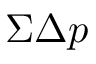Convert formula to latex. <formula><loc_0><loc_0><loc_500><loc_500>\Sigma \Delta p</formula> 